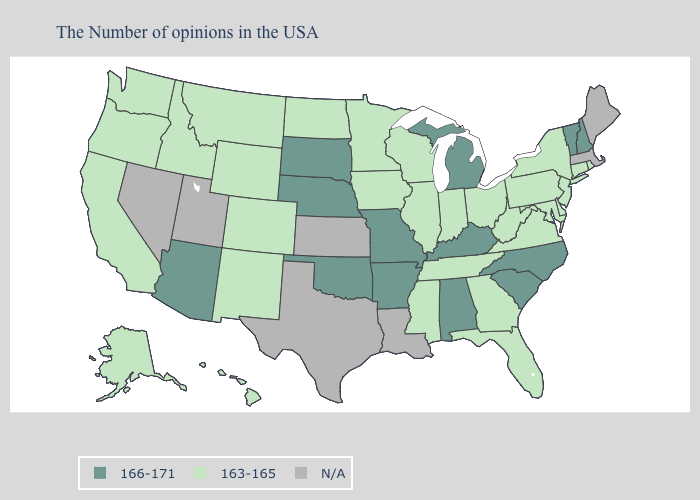Name the states that have a value in the range N/A?
Short answer required. Maine, Massachusetts, Louisiana, Kansas, Texas, Utah, Nevada. What is the lowest value in states that border Tennessee?
Keep it brief. 163-165. Name the states that have a value in the range N/A?
Quick response, please. Maine, Massachusetts, Louisiana, Kansas, Texas, Utah, Nevada. Name the states that have a value in the range N/A?
Concise answer only. Maine, Massachusetts, Louisiana, Kansas, Texas, Utah, Nevada. Does the first symbol in the legend represent the smallest category?
Keep it brief. No. Does Indiana have the highest value in the MidWest?
Write a very short answer. No. Name the states that have a value in the range 163-165?
Keep it brief. Rhode Island, Connecticut, New York, New Jersey, Delaware, Maryland, Pennsylvania, Virginia, West Virginia, Ohio, Florida, Georgia, Indiana, Tennessee, Wisconsin, Illinois, Mississippi, Minnesota, Iowa, North Dakota, Wyoming, Colorado, New Mexico, Montana, Idaho, California, Washington, Oregon, Alaska, Hawaii. What is the lowest value in the MidWest?
Be succinct. 163-165. Name the states that have a value in the range 166-171?
Concise answer only. New Hampshire, Vermont, North Carolina, South Carolina, Michigan, Kentucky, Alabama, Missouri, Arkansas, Nebraska, Oklahoma, South Dakota, Arizona. Name the states that have a value in the range 166-171?
Short answer required. New Hampshire, Vermont, North Carolina, South Carolina, Michigan, Kentucky, Alabama, Missouri, Arkansas, Nebraska, Oklahoma, South Dakota, Arizona. What is the value of Massachusetts?
Quick response, please. N/A. Which states have the lowest value in the MidWest?
Write a very short answer. Ohio, Indiana, Wisconsin, Illinois, Minnesota, Iowa, North Dakota. What is the highest value in the USA?
Be succinct. 166-171. 